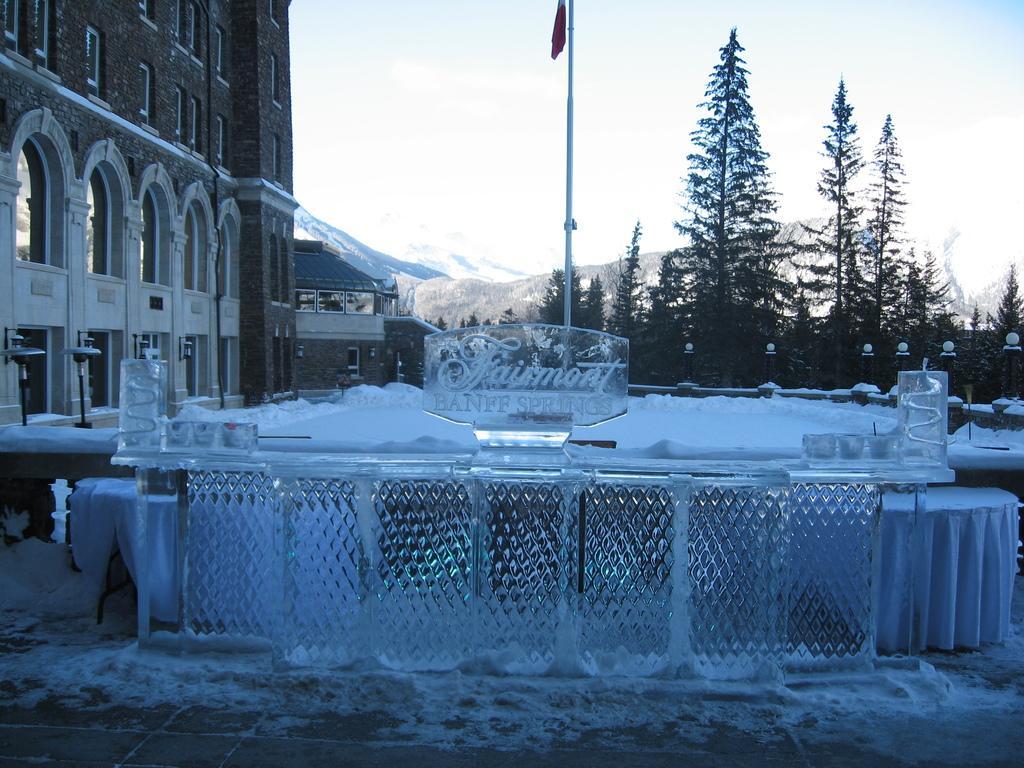Could you give a brief overview of what you see in this image? In this picture we can see buildings with windows, trees, pole, mountains and in the background we can see the sky. 